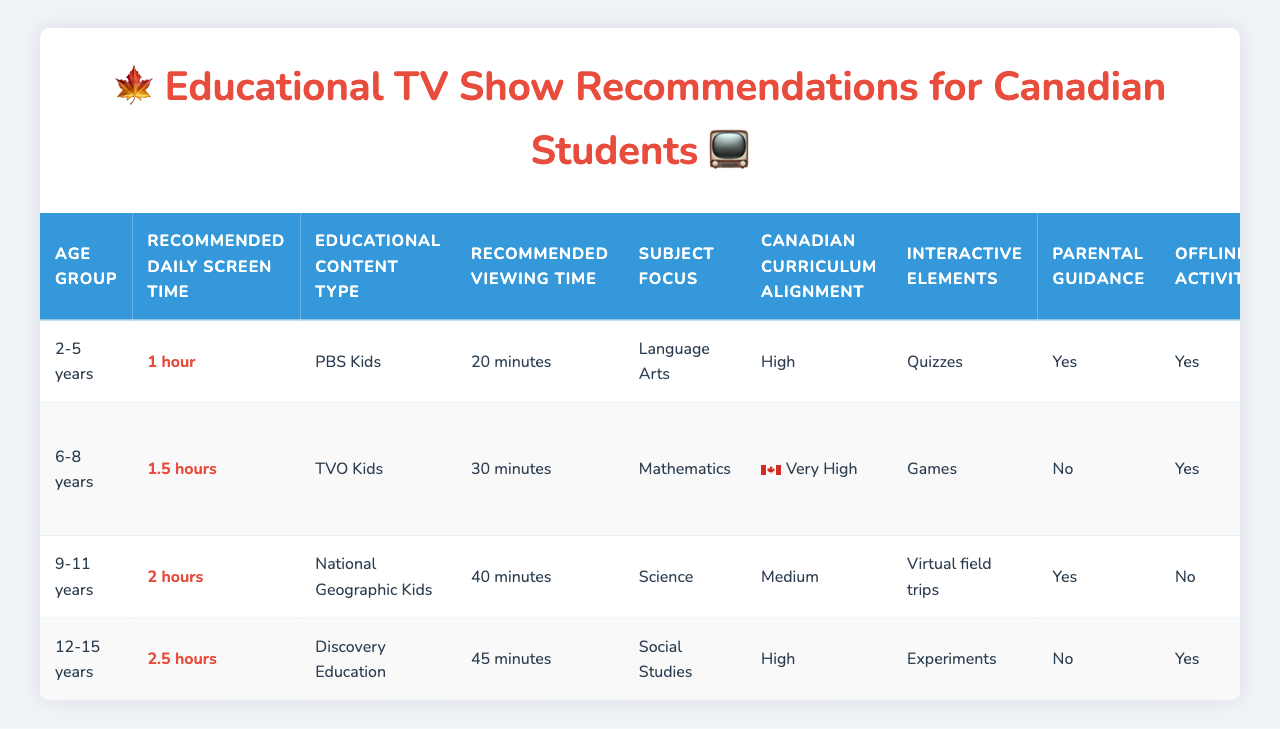What is the recommended daily screen time for children aged 2-5 years? The table lists "1 hour" as the recommended daily screen time for the 2-5 years age group.
Answer: 1 hour Which educational content type has a very high Canadian curriculum alignment? The content type with a very high alignment to the Canadian curriculum is "TVO Kids."
Answer: TVO Kids How long is the recommended viewing time for National Geographic Kids? According to the table, the recommended viewing time for National Geographic Kids is "40 minutes."
Answer: 40 minutes What is the total recommended viewing time across all educational content types for children aged 6-8 years? The viewing times for the 6-8 years age group are 30 minutes (TVO Kids), 40 minutes (National Geographic Kids), and 45 minutes (Discovery Education). Adding these gives 30 + 40 + 45 = 115 minutes.
Answer: 115 minutes Is parental guidance recommended for PBS Kids? The table indicates "Yes" for PBS Kids in the parental guidance column.
Answer: Yes Which age group has the highest recommended daily screen time? The age group with the highest recommended daily screen time is 12-15 years with "2.5 hours."
Answer: 12-15 years For children aged 9-11 years, which educational content type provides offline activities? The table shows that National Geographic Kids does not include offline activities, while Discovery Education, BrainPOP, and PBS Kids do.
Answer: Discovery Education, BrainPOP, PBS Kids What is the average recommended viewing time per content type? The recommended viewing times per content type are 20, 30, 40, 45, and 35 minutes. The average is (20 + 30 + 40 + 45 + 35)/5 = 34 minutes.
Answer: 34 minutes How many content types include interactive elements related to the subject of Arts and Creativity? The only content related to Arts and Creativity is BrainPOP, which has interactive elements as per the table, making it one.
Answer: 1 What is the language option available for National Geographic Kids? The table specifies that the language option available for National Geographic Kids is "English."
Answer: English 